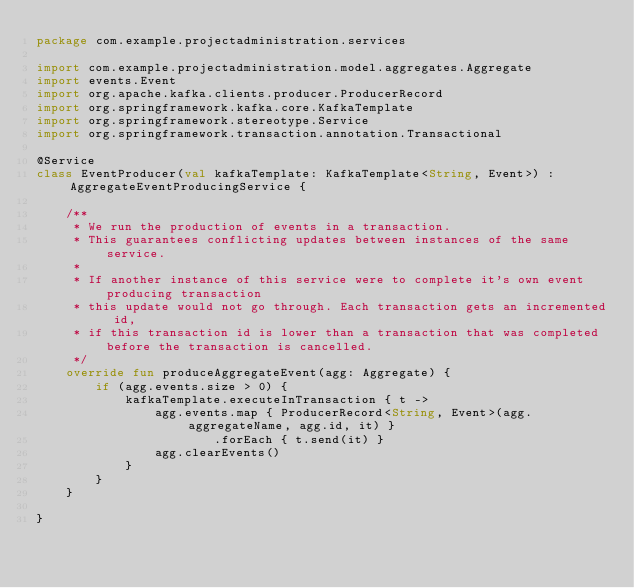<code> <loc_0><loc_0><loc_500><loc_500><_Kotlin_>package com.example.projectadministration.services

import com.example.projectadministration.model.aggregates.Aggregate
import events.Event
import org.apache.kafka.clients.producer.ProducerRecord
import org.springframework.kafka.core.KafkaTemplate
import org.springframework.stereotype.Service
import org.springframework.transaction.annotation.Transactional

@Service
class EventProducer(val kafkaTemplate: KafkaTemplate<String, Event>) : AggregateEventProducingService {

    /**
     * We run the production of events in a transaction.
     * This guarantees conflicting updates between instances of the same service.
     *
     * If another instance of this service were to complete it's own event producing transaction
     * this update would not go through. Each transaction gets an incremented id,
     * if this transaction id is lower than a transaction that was completed before the transaction is cancelled.
     */
    override fun produceAggregateEvent(agg: Aggregate) {
        if (agg.events.size > 0) {
            kafkaTemplate.executeInTransaction { t ->
                agg.events.map { ProducerRecord<String, Event>(agg.aggregateName, agg.id, it) }
                        .forEach { t.send(it) }
                agg.clearEvents()
            }
        }
    }

}</code> 